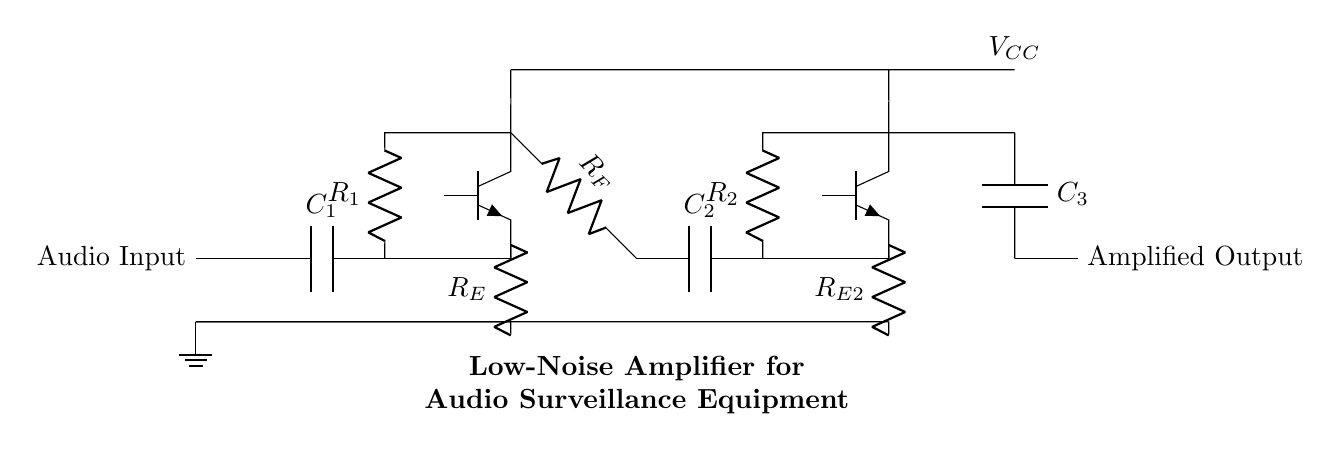What is the type of transistors used in this circuit? The circuit uses NPN transistors, which are indicated by the symbol Tnpn in the diagram.
Answer: NPN What is the function of capacitor C1? Capacitor C1 acts as a coupling capacitor that blocks any DC component in the audio input signal, allowing only the AC component to pass through to the rest of the circuit.
Answer: Coupling What is the purpose of resistor R_E? Resistor R_E serves as an emitter resistor, providing stability by setting the operating point of the transistor Q1 and helping to reduce distortion in the amplified signal.
Answer: Stability How many stages of amplification are there in this circuit? The circuit consists of two amplifying stages, each utilizing a transistor and associated components to amplify the audio signal.
Answer: Two What is the role of feedback resistor R_F? Feedback resistor R_F is used to control gain and stabilize the amplifier by providing negative feedback to the transistor Q1, which improves linearity and reduces noise.
Answer: Gain control What supply voltage is expected in the circuit? The circuit shows a power supply connected to the transistors, labeled as V_CC, indicating that it provides a positive voltage necessary for the operation of the amplifying stages.
Answer: V_CC 